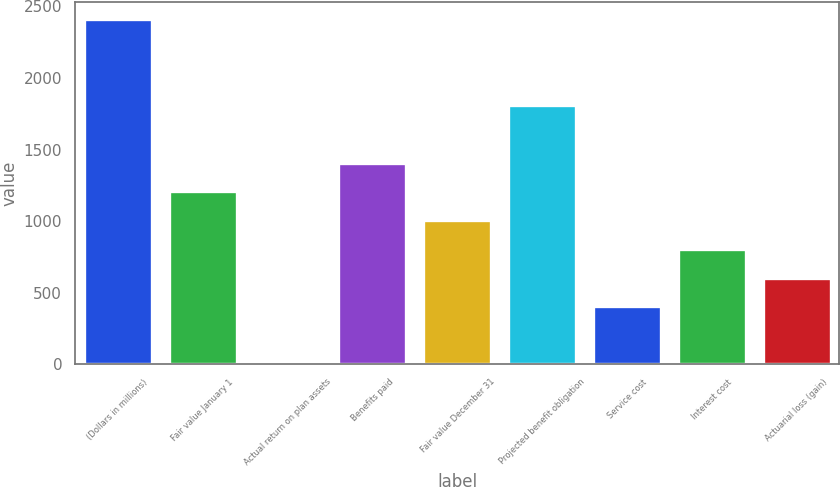<chart> <loc_0><loc_0><loc_500><loc_500><bar_chart><fcel>(Dollars in millions)<fcel>Fair value January 1<fcel>Actual return on plan assets<fcel>Benefits paid<fcel>Fair value December 31<fcel>Projected benefit obligation<fcel>Service cost<fcel>Interest cost<fcel>Actuarial loss (gain)<nl><fcel>2412.8<fcel>1207.4<fcel>2<fcel>1408.3<fcel>1006.5<fcel>1810.1<fcel>403.8<fcel>805.6<fcel>604.7<nl></chart> 